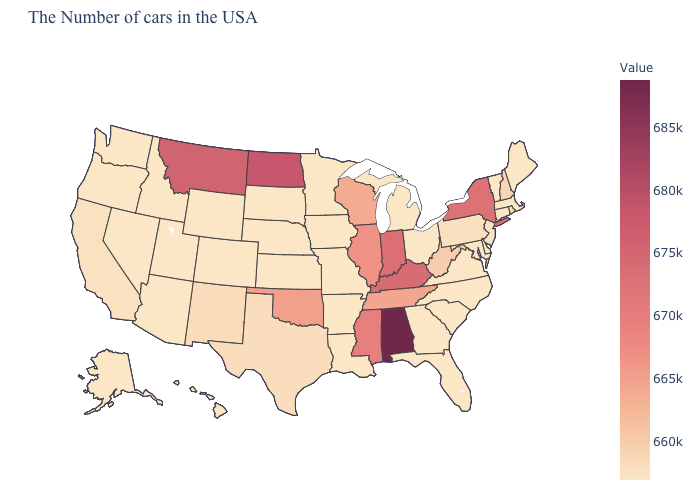Is the legend a continuous bar?
Short answer required. Yes. Among the states that border North Carolina , which have the lowest value?
Give a very brief answer. Virginia, South Carolina, Georgia. Which states hav the highest value in the MidWest?
Keep it brief. North Dakota. Does the map have missing data?
Concise answer only. No. Among the states that border Maryland , does Delaware have the highest value?
Be succinct. No. 